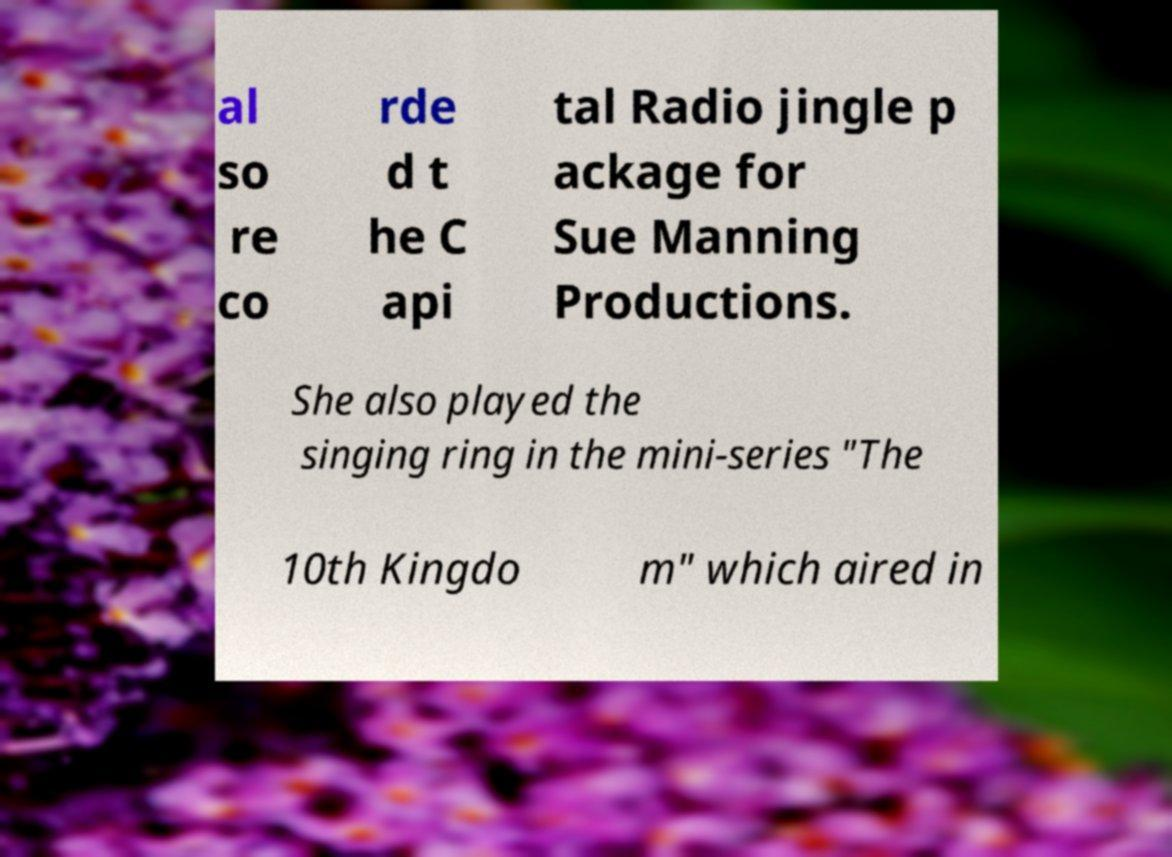For documentation purposes, I need the text within this image transcribed. Could you provide that? al so re co rde d t he C api tal Radio jingle p ackage for Sue Manning Productions. She also played the singing ring in the mini-series "The 10th Kingdo m" which aired in 